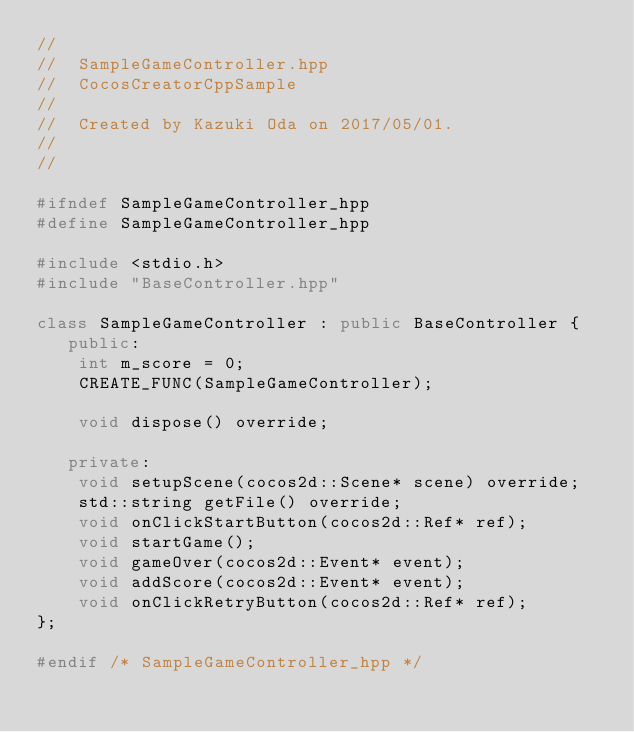Convert code to text. <code><loc_0><loc_0><loc_500><loc_500><_C++_>//
//  SampleGameController.hpp
//  CocosCreatorCppSample
//
//  Created by Kazuki Oda on 2017/05/01.
//
//

#ifndef SampleGameController_hpp
#define SampleGameController_hpp

#include <stdio.h>
#include "BaseController.hpp"

class SampleGameController : public BaseController {
   public:
    int m_score = 0;
    CREATE_FUNC(SampleGameController);

    void dispose() override;

   private:
    void setupScene(cocos2d::Scene* scene) override;
    std::string getFile() override;
    void onClickStartButton(cocos2d::Ref* ref);
    void startGame();
    void gameOver(cocos2d::Event* event);
    void addScore(cocos2d::Event* event);
    void onClickRetryButton(cocos2d::Ref* ref);
};

#endif /* SampleGameController_hpp */
</code> 